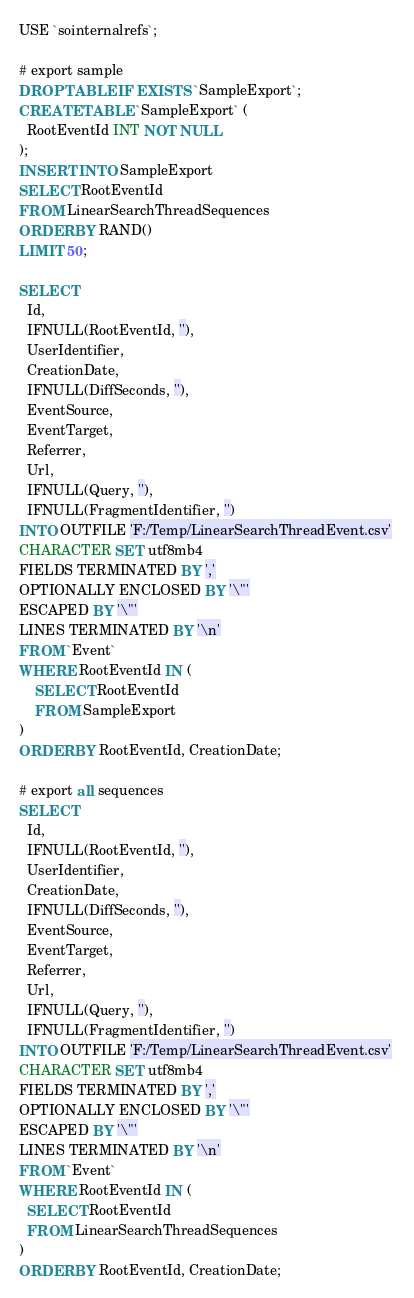<code> <loc_0><loc_0><loc_500><loc_500><_SQL_>USE `sointernalrefs`;

# export sample
DROP TABLE IF EXISTS `SampleExport`;
CREATE TABLE `SampleExport` (
  RootEventId INT NOT NULL
);
INSERT INTO SampleExport
SELECT RootEventId
FROM LinearSearchThreadSequences
ORDER BY RAND()
LIMIT 50;

SELECT
  Id,
  IFNULL(RootEventId, ''),
  UserIdentifier,
  CreationDate,
  IFNULL(DiffSeconds, ''),
  EventSource,
  EventTarget,
  Referrer,
  Url,
  IFNULL(Query, ''),
  IFNULL(FragmentIdentifier, '')
INTO OUTFILE 'F:/Temp/LinearSearchThreadEvent.csv' 
CHARACTER SET utf8mb4
FIELDS TERMINATED BY ','
OPTIONALLY ENCLOSED BY '\"'
ESCAPED BY '\"'
LINES TERMINATED BY '\n'
FROM `Event`
WHERE RootEventId IN (
	SELECT RootEventId
	FROM SampleExport
)
ORDER BY RootEventId, CreationDate;

# export all sequences
SELECT
  Id,
  IFNULL(RootEventId, ''),
  UserIdentifier,
  CreationDate,
  IFNULL(DiffSeconds, ''),
  EventSource,
  EventTarget,
  Referrer,
  Url,
  IFNULL(Query, ''),
  IFNULL(FragmentIdentifier, '')
INTO OUTFILE 'F:/Temp/LinearSearchThreadEvent.csv' 
CHARACTER SET utf8mb4
FIELDS TERMINATED BY ','
OPTIONALLY ENCLOSED BY '\"'
ESCAPED BY '\"'
LINES TERMINATED BY '\n'
FROM `Event`
WHERE RootEventId IN (
  SELECT RootEventId
  FROM LinearSearchThreadSequences
)
ORDER BY RootEventId, CreationDate;
</code> 